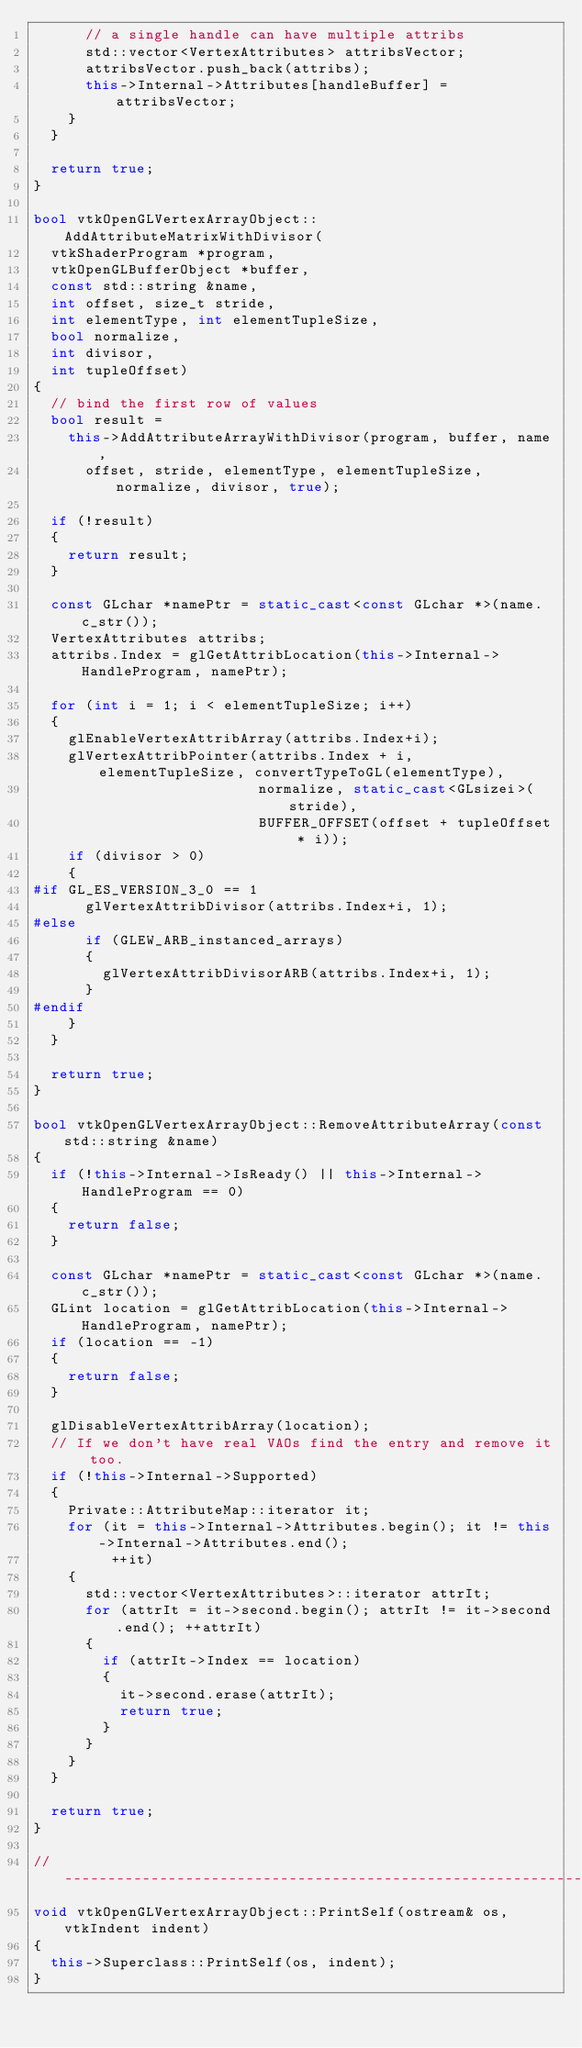<code> <loc_0><loc_0><loc_500><loc_500><_C++_>      // a single handle can have multiple attribs
      std::vector<VertexAttributes> attribsVector;
      attribsVector.push_back(attribs);
      this->Internal->Attributes[handleBuffer] = attribsVector;
    }
  }

  return true;
}

bool vtkOpenGLVertexArrayObject::AddAttributeMatrixWithDivisor(
  vtkShaderProgram *program,
  vtkOpenGLBufferObject *buffer,
  const std::string &name,
  int offset, size_t stride,
  int elementType, int elementTupleSize,
  bool normalize,
  int divisor,
  int tupleOffset)
{
  // bind the first row of values
  bool result =
    this->AddAttributeArrayWithDivisor(program, buffer, name,
      offset, stride, elementType, elementTupleSize, normalize, divisor, true);

  if (!result)
  {
    return result;
  }

  const GLchar *namePtr = static_cast<const GLchar *>(name.c_str());
  VertexAttributes attribs;
  attribs.Index = glGetAttribLocation(this->Internal->HandleProgram, namePtr);

  for (int i = 1; i < elementTupleSize; i++)
  {
    glEnableVertexAttribArray(attribs.Index+i);
    glVertexAttribPointer(attribs.Index + i, elementTupleSize, convertTypeToGL(elementType),
                          normalize, static_cast<GLsizei>(stride),
                          BUFFER_OFFSET(offset + tupleOffset * i));
    if (divisor > 0)
    {
#if GL_ES_VERSION_3_0 == 1
      glVertexAttribDivisor(attribs.Index+i, 1);
#else
      if (GLEW_ARB_instanced_arrays)
      {
        glVertexAttribDivisorARB(attribs.Index+i, 1);
      }
#endif
    }
  }

  return true;
}

bool vtkOpenGLVertexArrayObject::RemoveAttributeArray(const std::string &name)
{
  if (!this->Internal->IsReady() || this->Internal->HandleProgram == 0)
  {
    return false;
  }

  const GLchar *namePtr = static_cast<const GLchar *>(name.c_str());
  GLint location = glGetAttribLocation(this->Internal->HandleProgram, namePtr);
  if (location == -1)
  {
    return false;
  }

  glDisableVertexAttribArray(location);
  // If we don't have real VAOs find the entry and remove it too.
  if (!this->Internal->Supported)
  {
    Private::AttributeMap::iterator it;
    for (it = this->Internal->Attributes.begin(); it != this->Internal->Attributes.end();
         ++it)
    {
      std::vector<VertexAttributes>::iterator attrIt;
      for (attrIt = it->second.begin(); attrIt != it->second.end(); ++attrIt)
      {
        if (attrIt->Index == location)
        {
          it->second.erase(attrIt);
          return true;
        }
      }
    }
  }

  return true;
}

//-----------------------------------------------------------------------------
void vtkOpenGLVertexArrayObject::PrintSelf(ostream& os, vtkIndent indent)
{
  this->Superclass::PrintSelf(os, indent);
}
</code> 